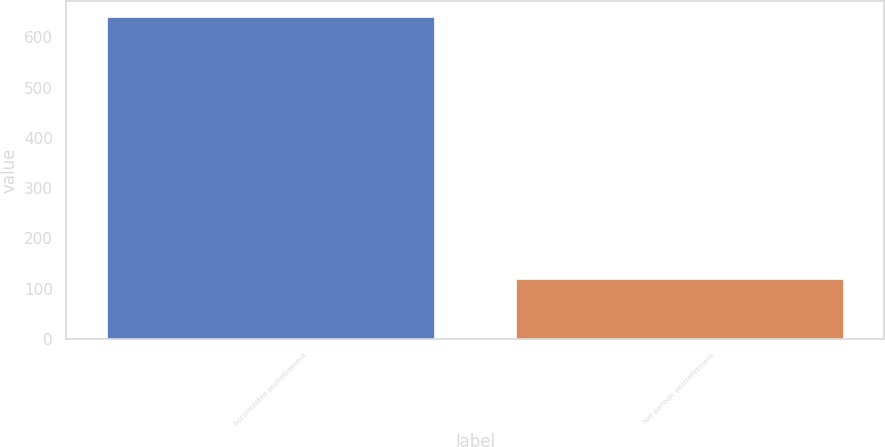Convert chart. <chart><loc_0><loc_0><loc_500><loc_500><bar_chart><fcel>Accumulated postretirement<fcel>Net periodic postretirement<nl><fcel>640<fcel>120<nl></chart> 